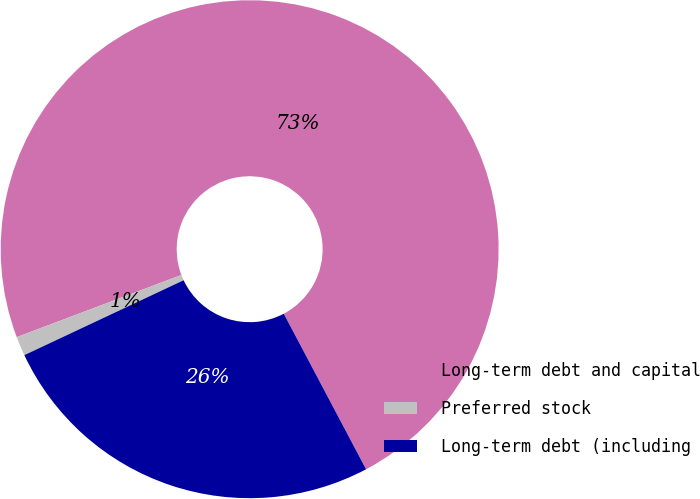Convert chart to OTSL. <chart><loc_0><loc_0><loc_500><loc_500><pie_chart><fcel>Long-term debt and capital<fcel>Preferred stock<fcel>Long-term debt (including<nl><fcel>73.0%<fcel>1.25%<fcel>25.75%<nl></chart> 